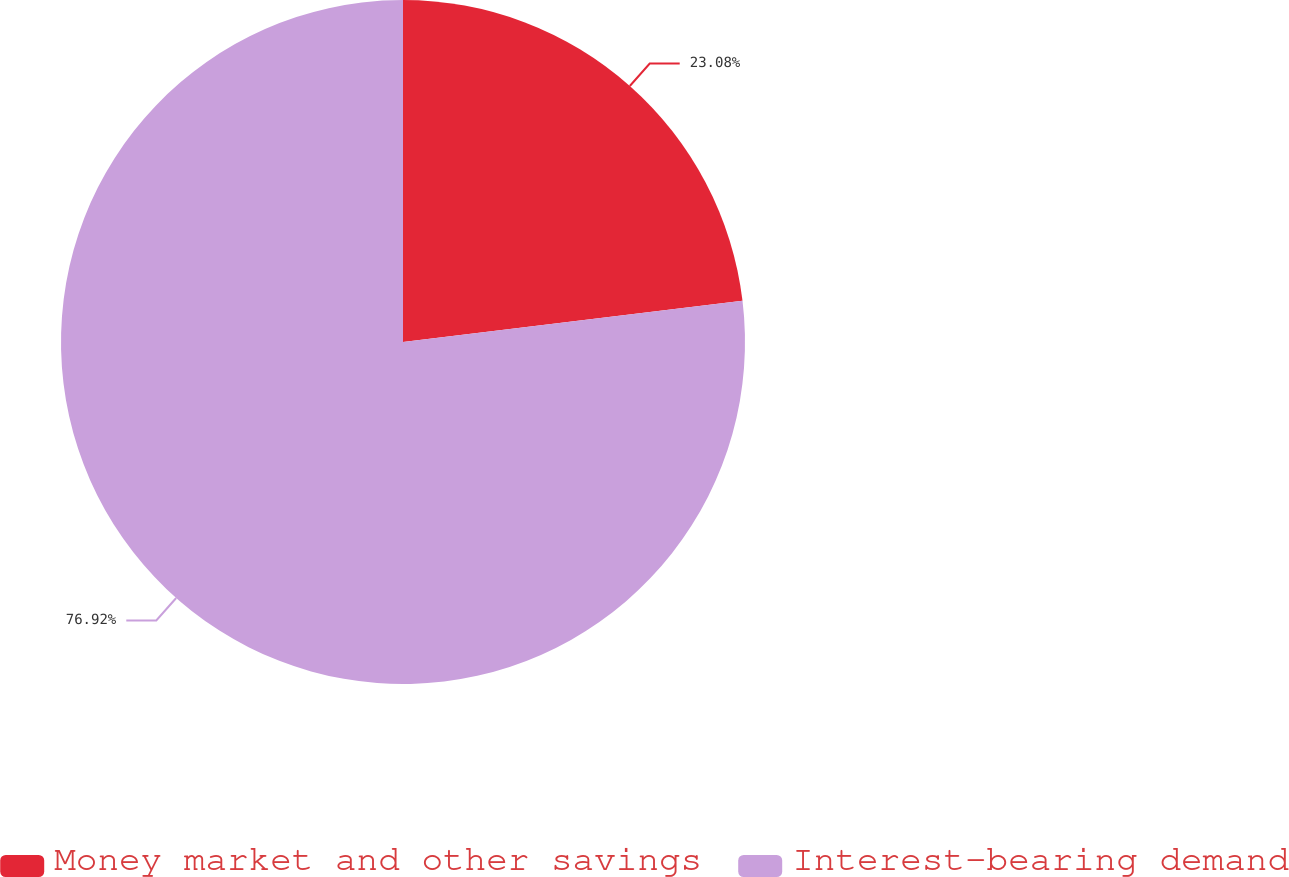Convert chart. <chart><loc_0><loc_0><loc_500><loc_500><pie_chart><fcel>Money market and other savings<fcel>Interest-bearing demand<nl><fcel>23.08%<fcel>76.92%<nl></chart> 